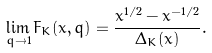<formula> <loc_0><loc_0><loc_500><loc_500>\lim _ { q \rightarrow 1 } F _ { K } ( x , q ) = \frac { x ^ { 1 / 2 } - x ^ { - 1 / 2 } } { \Delta _ { K } ( x ) } .</formula> 